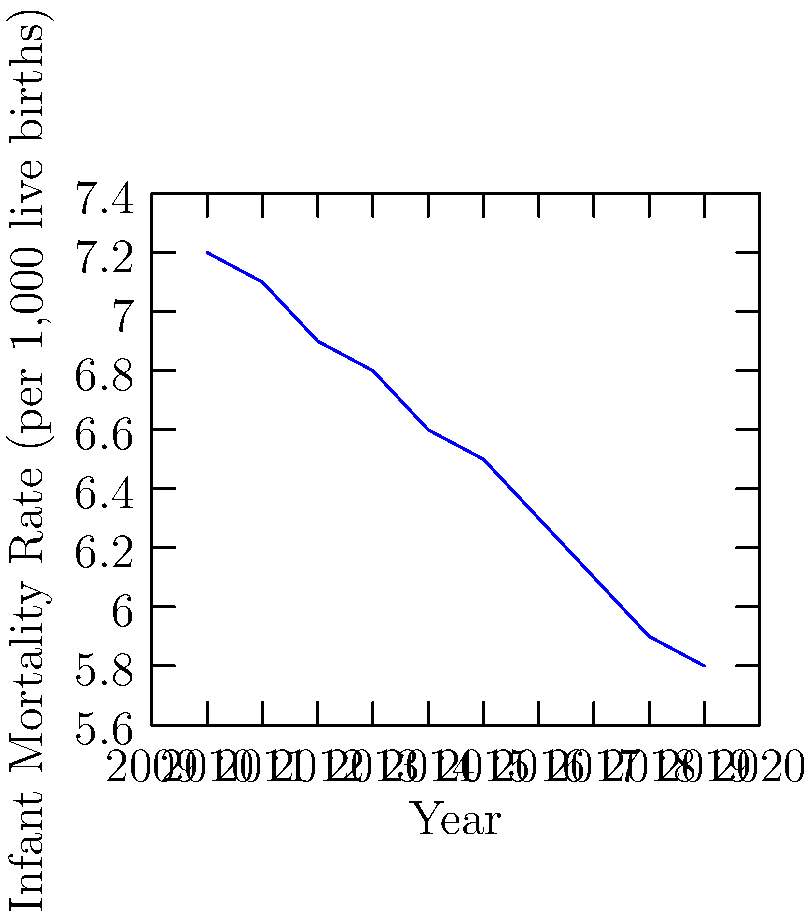Based on the line graph showing infant mortality rates in rural North Carolina from 2010 to 2019, what is the overall trend observed, and approximately how much did the rate decrease over this period? To answer this question, we need to analyze the line graph and follow these steps:

1. Observe the overall trend:
   The line graph shows a consistent downward trend from 2010 to 2019.

2. Identify the starting and ending points:
   - In 2010 (start): The infant mortality rate was approximately 7.2 per 1,000 live births.
   - In 2019 (end): The infant mortality rate was approximately 5.8 per 1,000 live births.

3. Calculate the total decrease:
   $7.2 - 5.8 = 1.4$ per 1,000 live births

4. Interpret the results:
   The infant mortality rate in rural North Carolina decreased by approximately 1.4 per 1,000 live births over the decade from 2010 to 2019.

Therefore, the overall trend is a steady decrease, with a total reduction of about 1.4 per 1,000 live births over the 10-year period.
Answer: Steady decrease; approximately 1.4 per 1,000 live births 